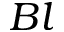<formula> <loc_0><loc_0><loc_500><loc_500>B l</formula> 